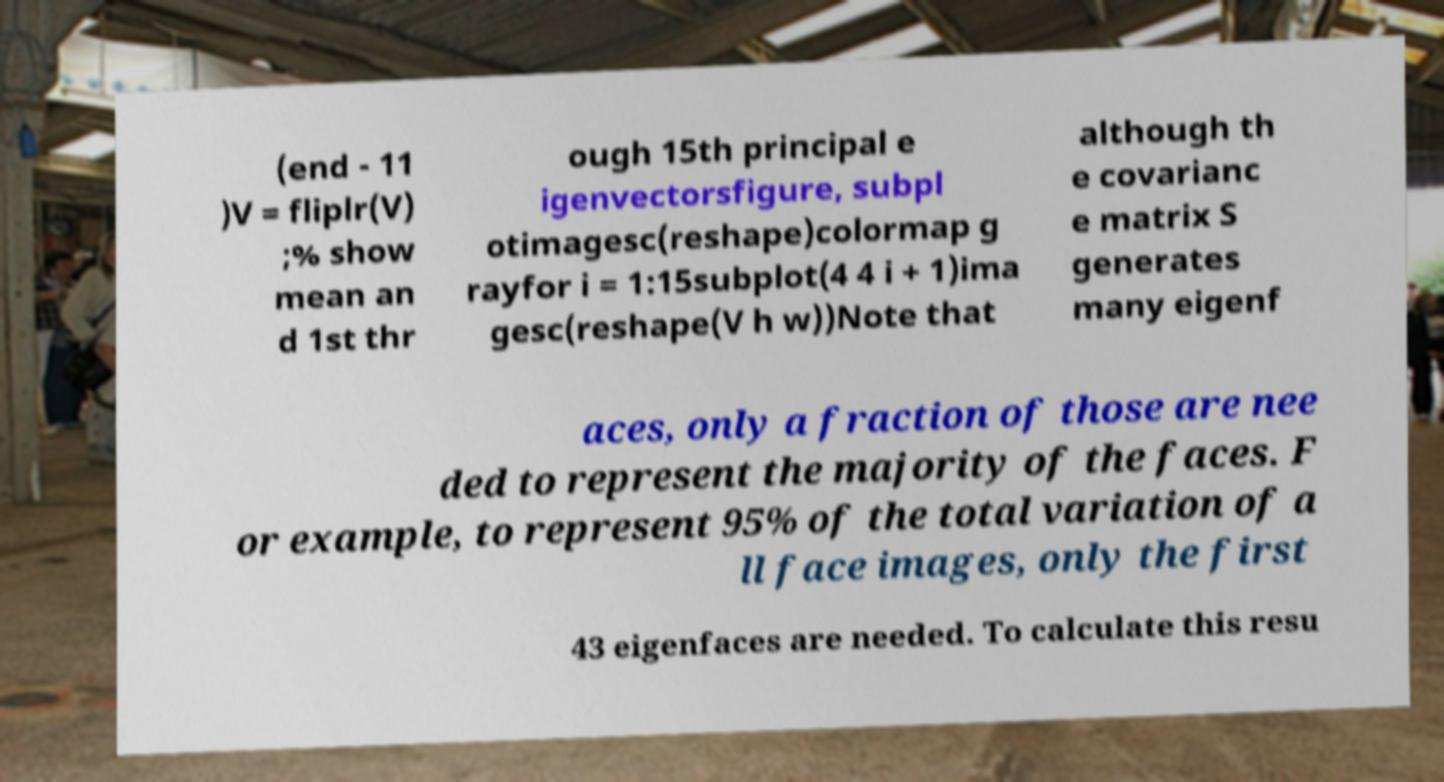Please read and relay the text visible in this image. What does it say? (end - 11 )V = fliplr(V) ;% show mean an d 1st thr ough 15th principal e igenvectorsfigure, subpl otimagesc(reshape)colormap g rayfor i = 1:15subplot(4 4 i + 1)ima gesc(reshape(V h w))Note that although th e covarianc e matrix S generates many eigenf aces, only a fraction of those are nee ded to represent the majority of the faces. F or example, to represent 95% of the total variation of a ll face images, only the first 43 eigenfaces are needed. To calculate this resu 